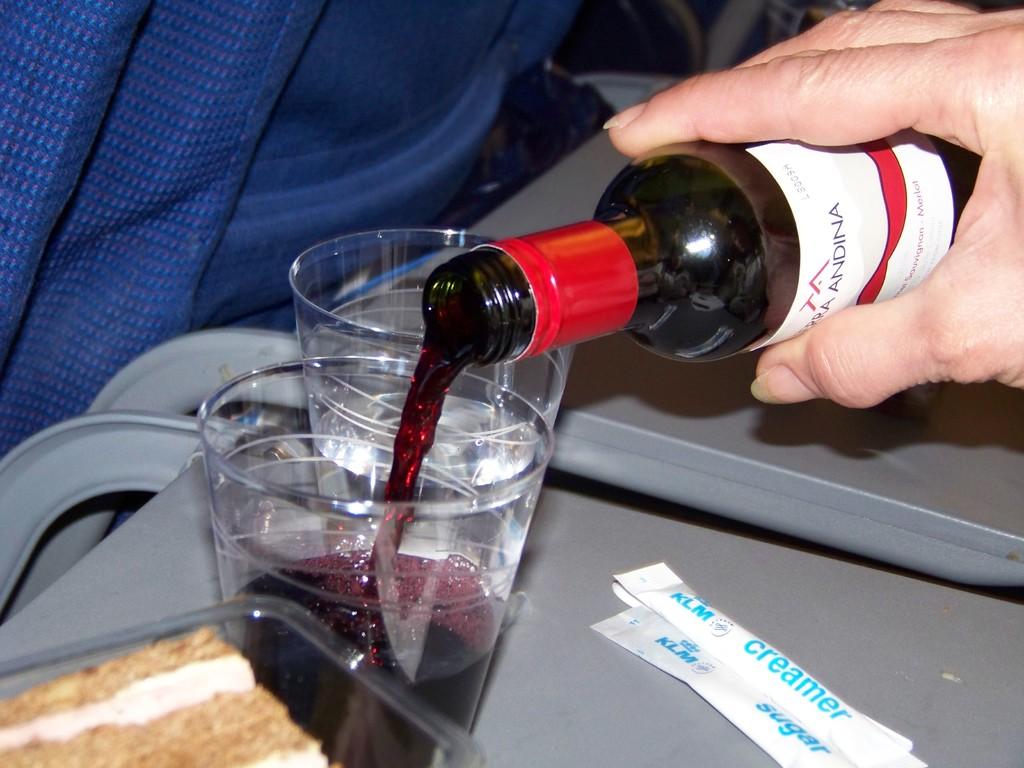What type of powder is on top of the sugar packet?
Give a very brief answer. Creamer. What is the drink's brand?
Make the answer very short. Andina. 